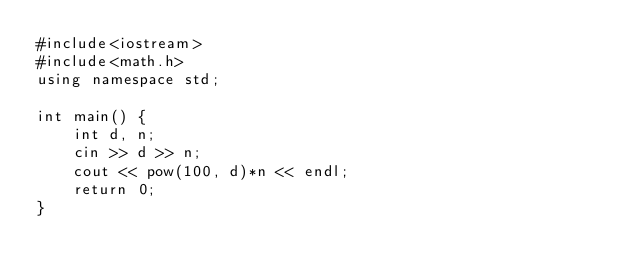Convert code to text. <code><loc_0><loc_0><loc_500><loc_500><_C++_>#include<iostream>
#include<math.h>
using namespace std;

int main() {
    int d, n;
    cin >> d >> n;
    cout << pow(100, d)*n << endl;
    return 0;
}</code> 